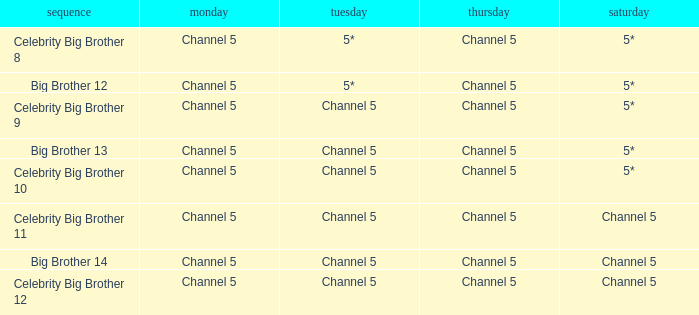Can you parse all the data within this table? {'header': ['sequence', 'monday', 'tuesday', 'thursday', 'saturday'], 'rows': [['Celebrity Big Brother 8', 'Channel 5', '5*', 'Channel 5', '5*'], ['Big Brother 12', 'Channel 5', '5*', 'Channel 5', '5*'], ['Celebrity Big Brother 9', 'Channel 5', 'Channel 5', 'Channel 5', '5*'], ['Big Brother 13', 'Channel 5', 'Channel 5', 'Channel 5', '5*'], ['Celebrity Big Brother 10', 'Channel 5', 'Channel 5', 'Channel 5', '5*'], ['Celebrity Big Brother 11', 'Channel 5', 'Channel 5', 'Channel 5', 'Channel 5'], ['Big Brother 14', 'Channel 5', 'Channel 5', 'Channel 5', 'Channel 5'], ['Celebrity Big Brother 12', 'Channel 5', 'Channel 5', 'Channel 5', 'Channel 5']]} Which series airs Saturday on Channel 5? Celebrity Big Brother 11, Big Brother 14, Celebrity Big Brother 12. 